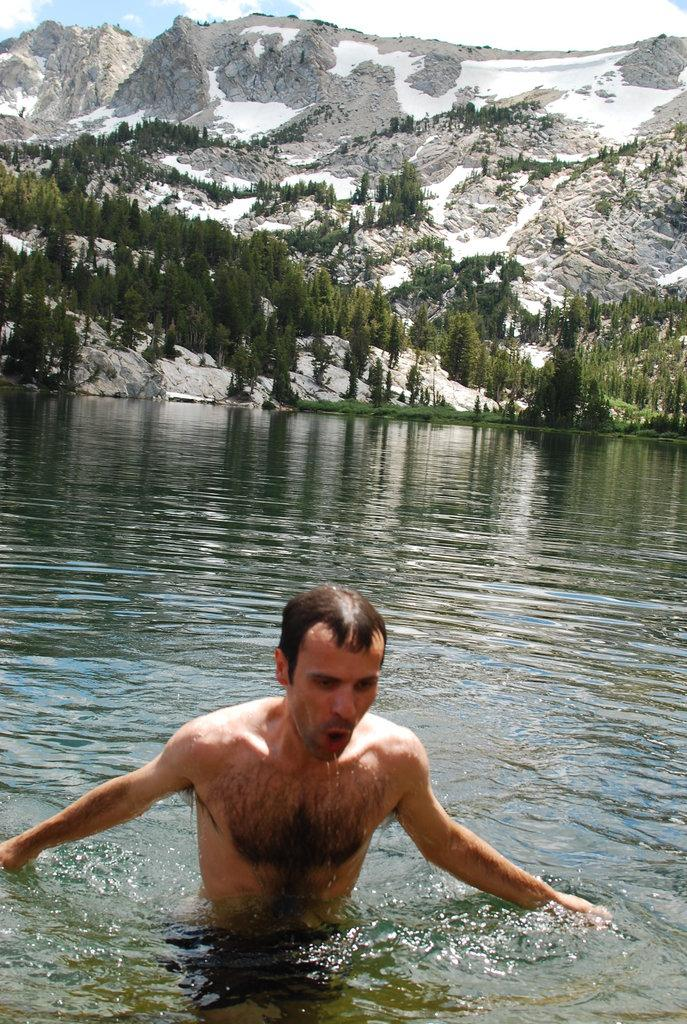What is the man in the image doing? The man is in the water in the image. What can be seen in the background of the image? There are trees and hills visible in the background of the image. What type of feast is the man attending in the image? There is no feast present in the image; the man is simply in the water. Can you compare the man's actions in the image to those of a lawyer? There is no lawyer present in the image, and the man's actions do not involve any legal activities. 